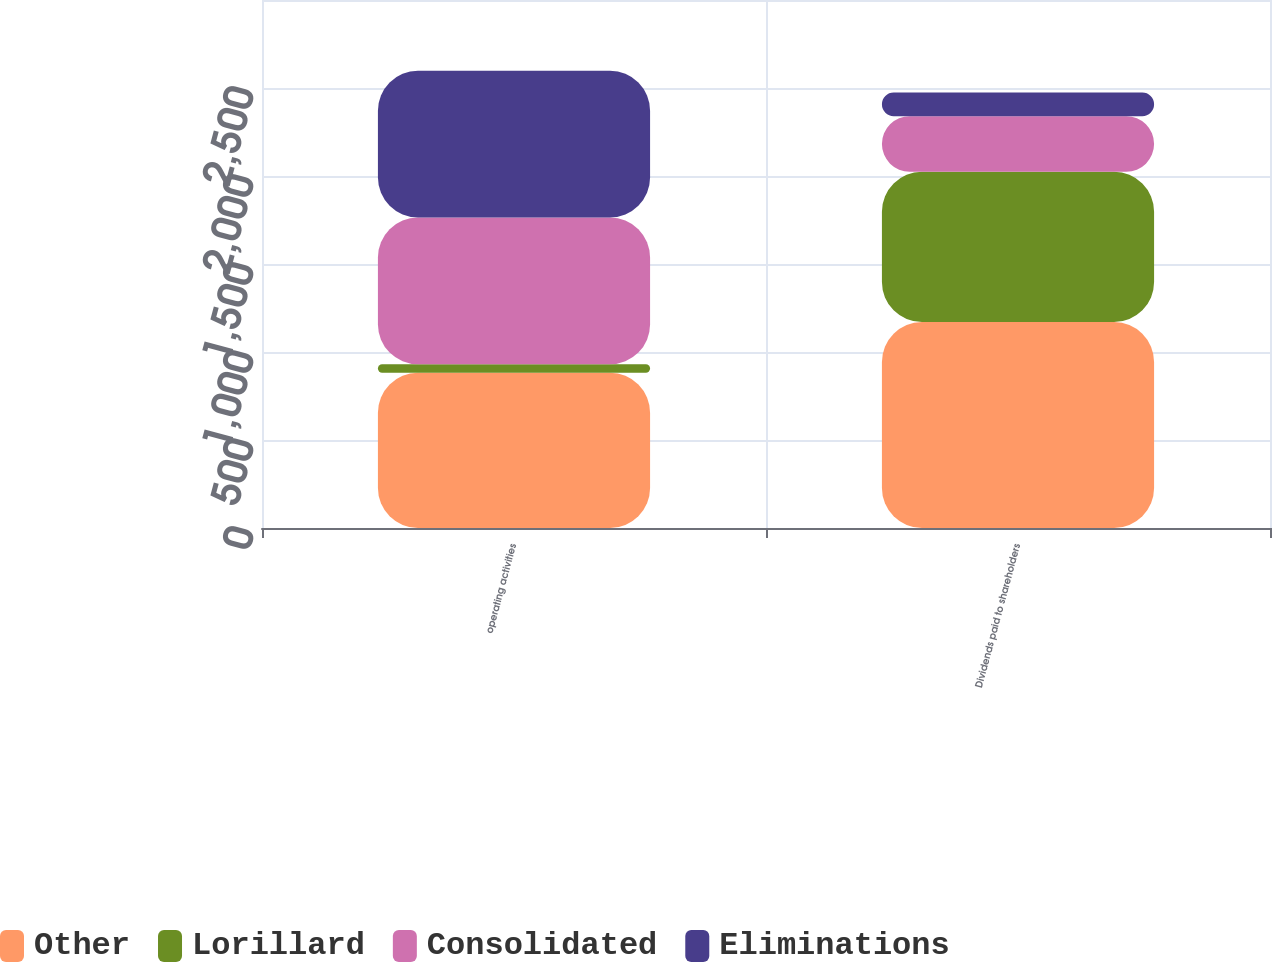Convert chart. <chart><loc_0><loc_0><loc_500><loc_500><stacked_bar_chart><ecel><fcel>operating activities<fcel>Dividends paid to shareholders<nl><fcel>Other<fcel>882<fcel>1170<nl><fcel>Lorillard<fcel>48<fcel>854<nl><fcel>Consolidated<fcel>834<fcel>316<nl><fcel>Eliminations<fcel>834<fcel>134<nl></chart> 